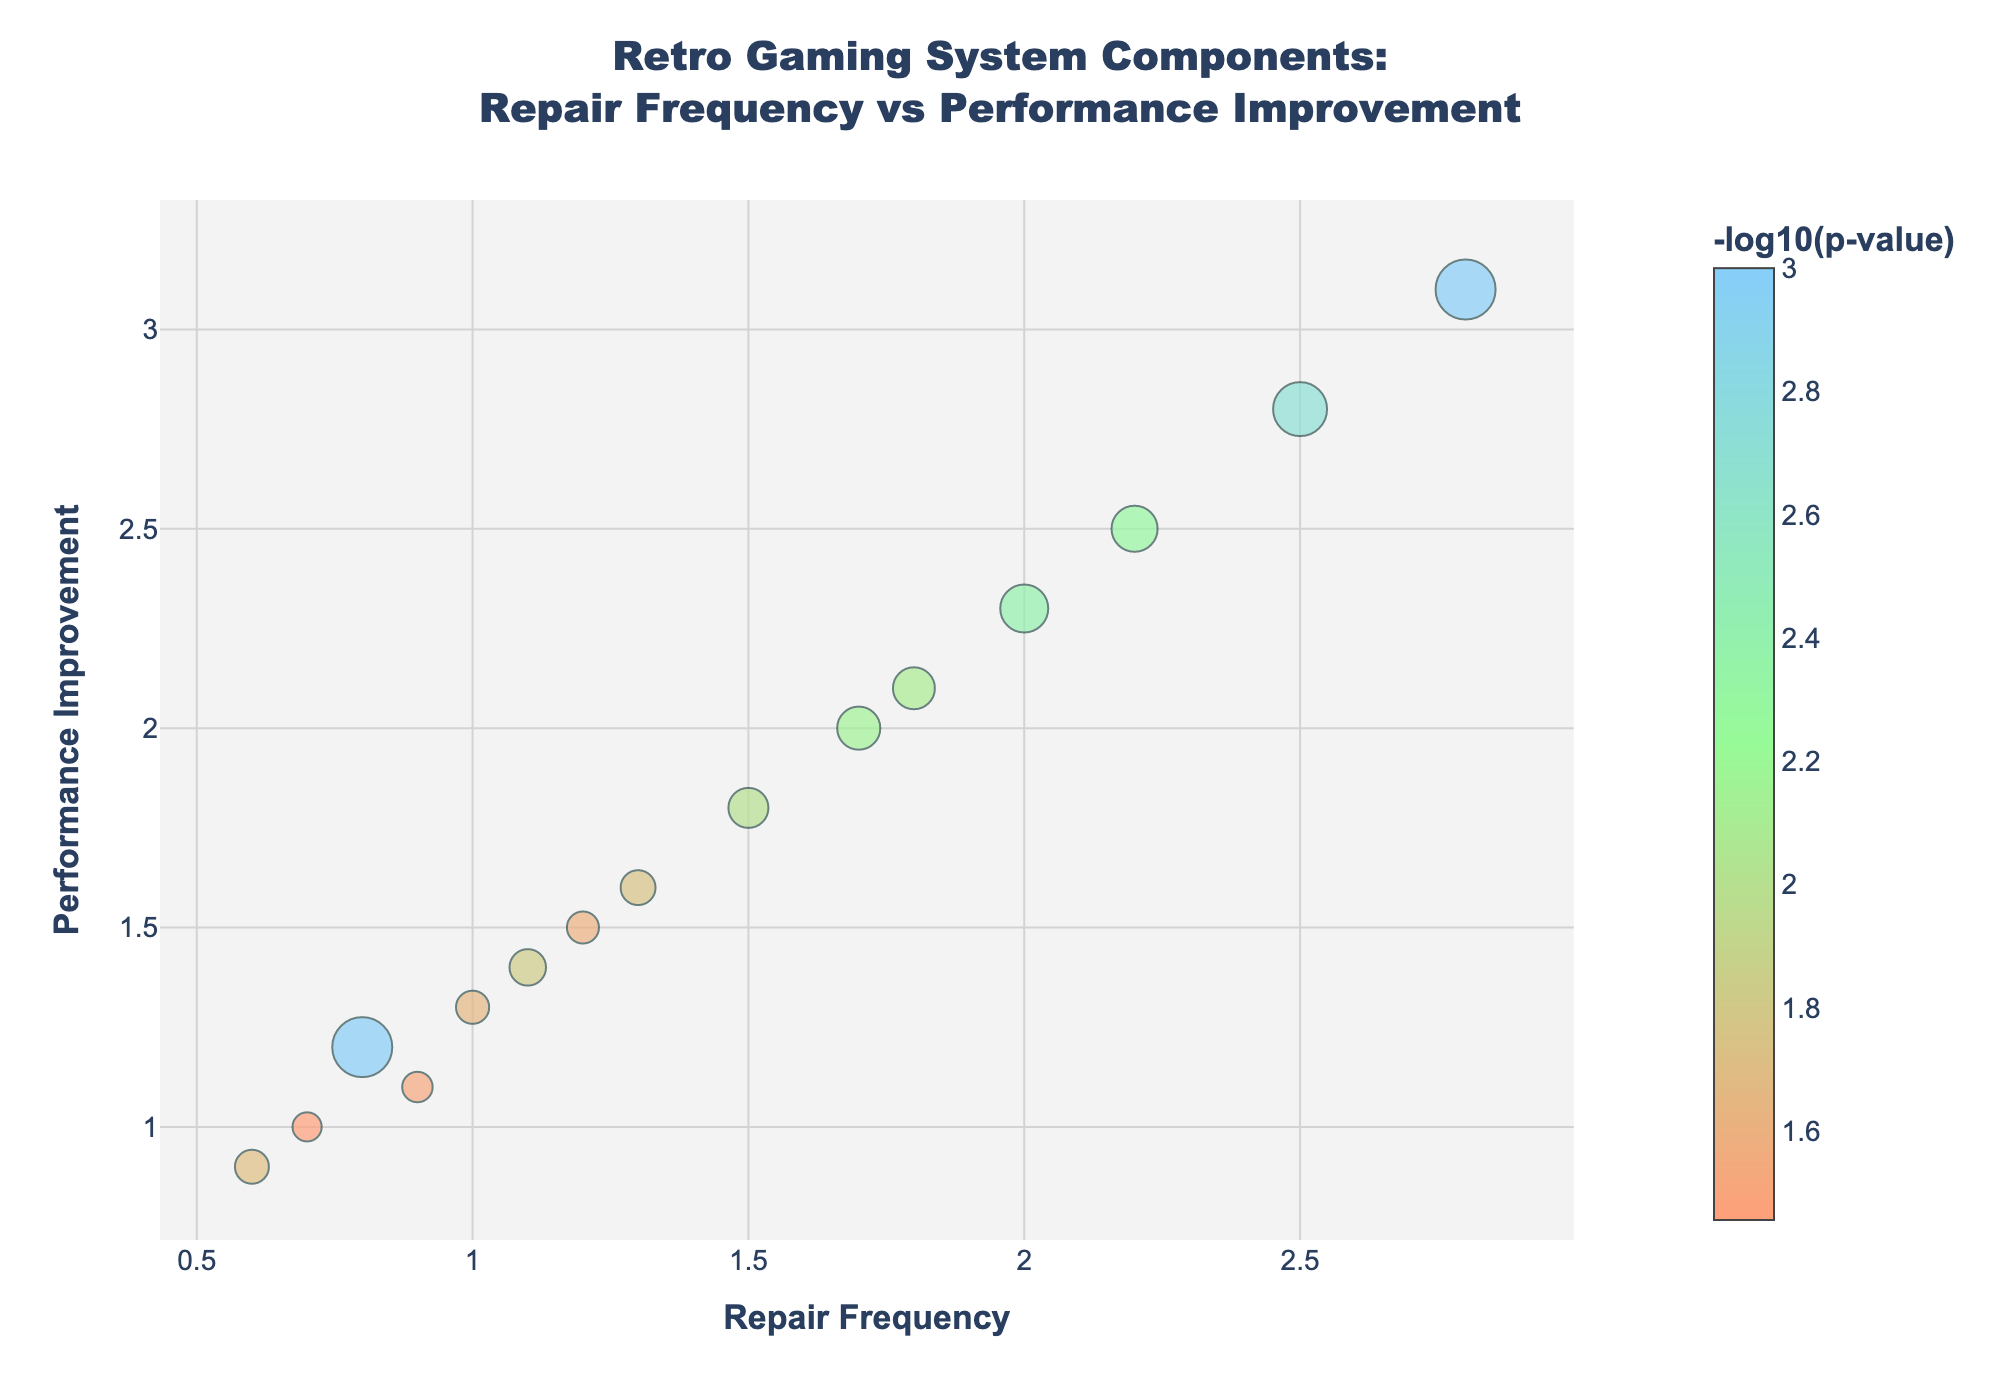What is the title of the plot? The title of the plot is located at the top center and provides an overview of the visualized data. It states "<b>Retro Gaming System Components:</b><br>Repair Frequency vs Performance Improvement."
Answer: Retro Gaming System Components: Repair Frequency vs Performance Improvement How many data points are displayed on the plot? Each component corresponds to one data point on the plot. By counting the number of unique markers, we determine there are 15 data points.
Answer: 15 Which component has the highest performance improvement? By looking at the y-axis where performance improvement is plotted, the highest performance improvement is represented by the highest marker on the y-axis. It is clear from the plot that the Game Gear Capacitors has the highest performance improvement with a value of 3.1.
Answer: Game Gear Capacitors How is the color of each data point determined? The color of each data point is determined by the -log10(p-value), shown in the color bar on the right. Data points with higher -log10(p-value) are represented by different colors in the provided scale.
Answer: By -log10(p-value) Which components have a repair frequency higher than 2.0 and what are their performance improvements? By examining the x-axis for points greater than 2.0 and matching them to their respective y-axis values, three points are identified: N64 Controller Joystick (2.5), Game Gear Capacitors (3.1), and PS2 Laser Assembly (2.3).
Answer: N64 Controller Joystick: 2.5, Game Gear Capacitors: 3.1, PS2 Laser Assembly: 2.3 What is the significance value range for all the components? The significance value of each component is represented by -log10(p-value). By looking at the color bar and the markers' colors and sizes, we can determine the range. The range of significance values spans from approximately 0.001 to 0.035.
Answer: 0.001 to 0.035 Which component has the smallest repair frequency but still shows performance improvement? By checking the minimum value on the x-axis and identifying the corresponding data point, the PlayStation DualShock with a repair frequency of 0.6 and performance improvement of 0.9 is identified.
Answer: PlayStation DualShock Compare the performance improvement of NES CPU and Xbox Hard Drive. Which one is greater and by how much? NES CPU has a performance improvement of 1.2, while Xbox Hard Drive has 2.0. The difference is 2.0 - 1.2 = 0.8, making Xbox Hard Drive's performance improvement greater by 0.8.
Answer: Xbox Hard Drive by 0.8 Which component has the highest -log10(p-value) and what does this indicate about its significance? The component with the highest -log10(p-value) has the largest bubble size, which is the Game Gear Capacitors. This indicates it has the smallest p-value, thus the highest statistical significance.
Answer: Game Gear Capacitors, highest significance How are the sizes of the markers related to the data? Marker sizes are proportional to the -log10(p-value). Larger markers indicate a more significant p-value (smaller actual p-value), while smaller markers indicate a less significant p-value.
Answer: Proportional to -log10(p-value) 